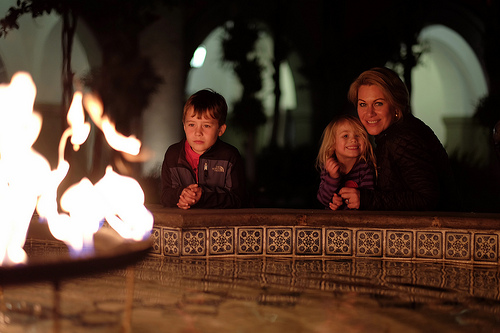<image>
Can you confirm if the boy is in front of the mom? No. The boy is not in front of the mom. The spatial positioning shows a different relationship between these objects. 